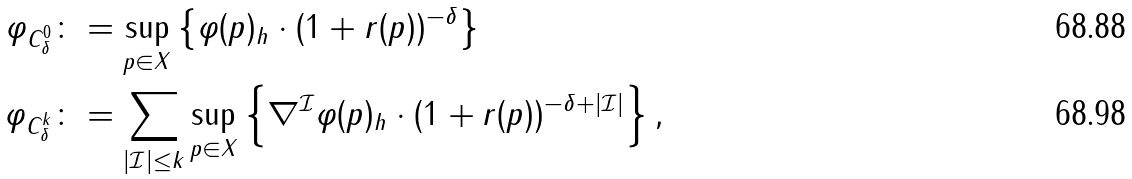<formula> <loc_0><loc_0><loc_500><loc_500>\| \varphi \| _ { C ^ { 0 } _ { \delta } } & \colon = \sup _ { p \in X } \left \{ \| \varphi ( p ) \| _ { h } \cdot ( 1 + r ( p ) ) ^ { - \delta } \right \} \\ \| \varphi \| _ { C ^ { k } _ { \delta } } & \colon = \sum _ { | \mathcal { I } | \leq k } \sup _ { p \in X } \left \{ \| \nabla ^ { \mathcal { I } } \varphi ( p ) \| _ { h } \cdot ( 1 + r ( p ) ) ^ { - \delta + | \mathcal { I } | } \right \} ,</formula> 